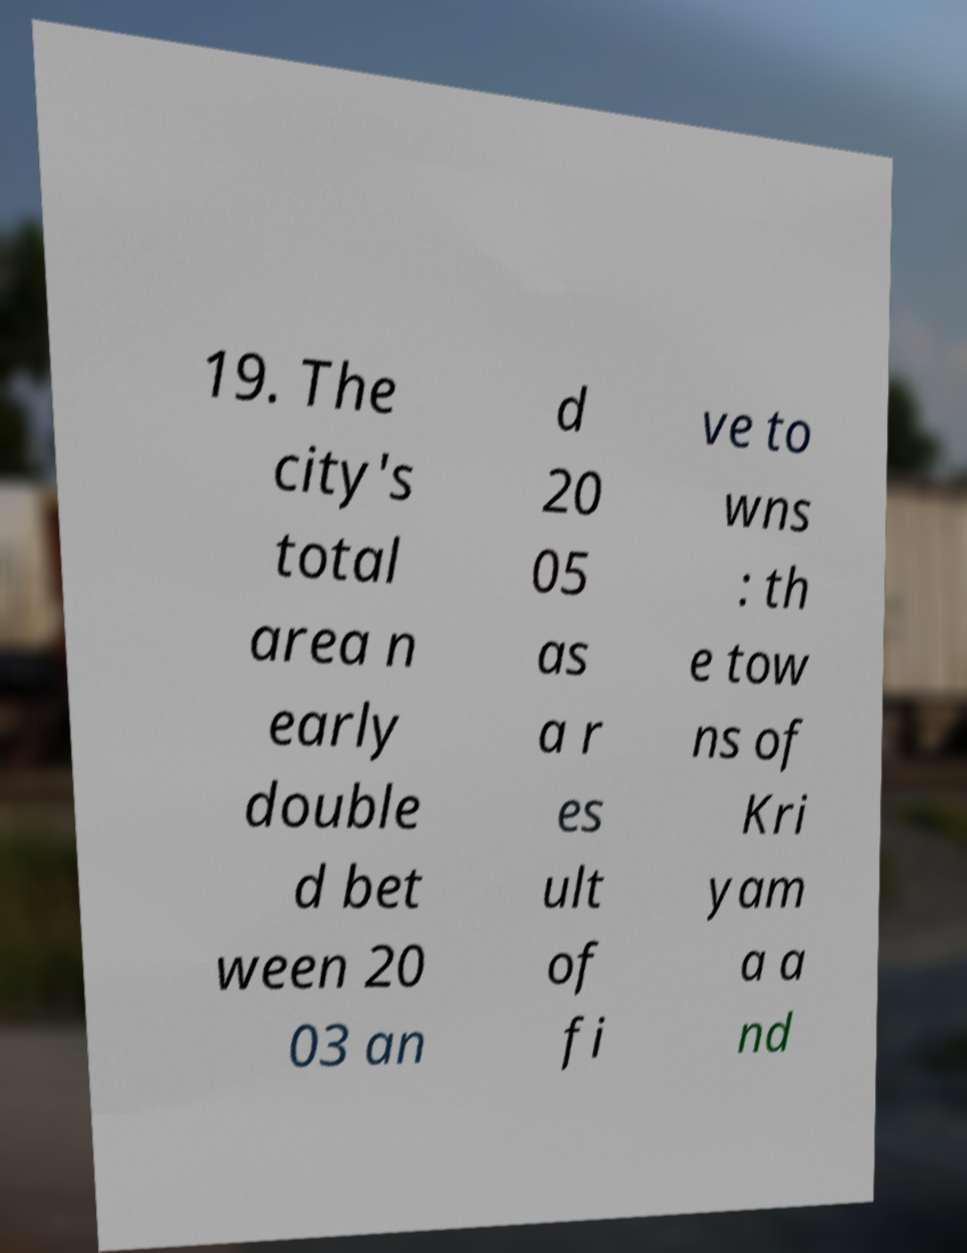Please identify and transcribe the text found in this image. 19. The city's total area n early double d bet ween 20 03 an d 20 05 as a r es ult of fi ve to wns : th e tow ns of Kri yam a a nd 